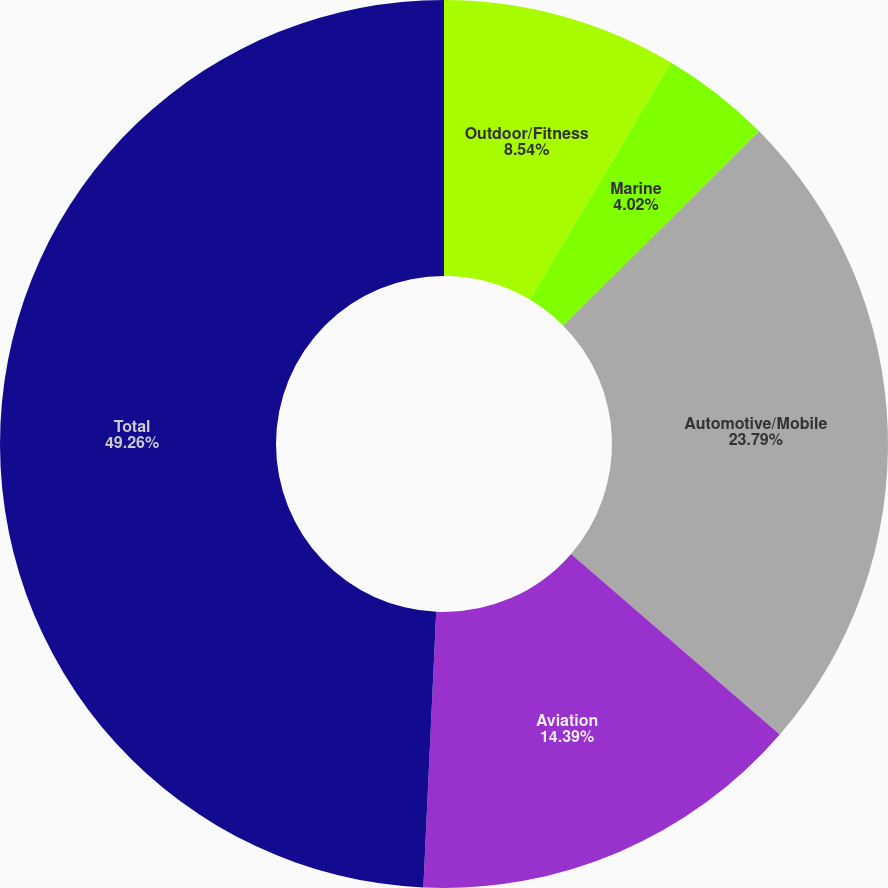Convert chart. <chart><loc_0><loc_0><loc_500><loc_500><pie_chart><fcel>Outdoor/Fitness<fcel>Marine<fcel>Automotive/Mobile<fcel>Aviation<fcel>Total<nl><fcel>8.54%<fcel>4.02%<fcel>23.79%<fcel>14.39%<fcel>49.26%<nl></chart> 